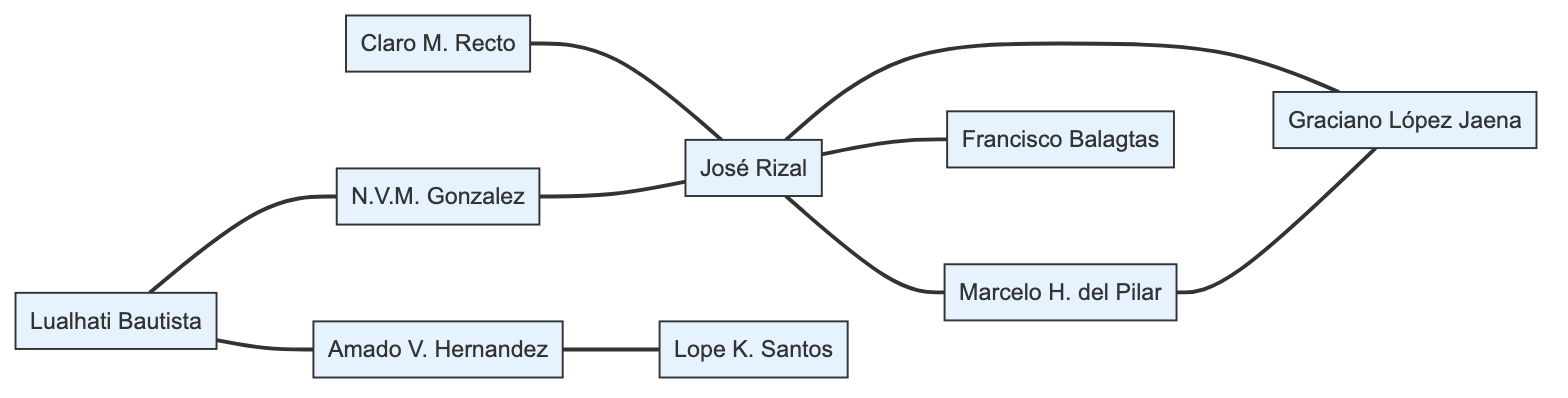What is the total number of nodes in the diagram? By counting the nodes listed in the data section, we find José Rizal, Marcelo H. del Pilar, Graciano López Jaena, Francisco Balagtas, Claro M. Recto, N.V.M. Gonzalez, Lope K. Santos, Amado V. Hernandez, and Lualhati Bautista. This gives us 9 distinct nodes.
Answer: 9 Who is mentored by Francisco Balagtas? In the data, there is an edge that shows a relationship between Francisco Balagtas and José Rizal denoting mentorship. Therefore, José Rizal is mentored by Francisco Balagtas.
Answer: José Rizal What is the relationship between Lualhati Bautista and Amado V. Hernandez? The diagram indicates that Lualhati Bautista has a mentoring relationship with Amado V. Hernandez, which is specified directly in the edges section of the data.
Answer: mentored Which author has the most peer relationships in this diagram? Upon reviewing the relationships, José Rizal has peer connections with Marcelo H. del Pilar, Graciano López Jaena, and indirectly with Francisco Balagtas. He has 3 peer connections, which is the highest when compared with others.
Answer: José Rizal How many relationships are indicated in the diagram? The edges section lists all relationships among the authors, counting each edge, we find there are 9 distinct relationships or edges in total that connect the nodes.
Answer: 9 Who inspired José Rizal? The data specifies that José Rizal was inspired by Claro M. Recto and N.V.M. Gonzalez. Both of these authors are depicted as edges leading to José Rizal with an "inspired_by" relationship.
Answer: Claro M. Recto, N.V.M. Gonzalez Is there an edge connecting N.V.M. Gonzalez to Amado V. Hernandez? Checking the edges section, N.V.M. Gonzalez is connected to Amado V. Hernandez only through Lualhati Bautista, but there is no direct edge between Gonzalez and Hernandez themselves.
Answer: No What type of relationship exists between Claro M. Recto and José Rizal? The relationship is classified as "inspired_by", indicating that there is a directional connection from Claro M. Recto towards José Rizal, reflecting an inspirational influence.
Answer: inspired_by 